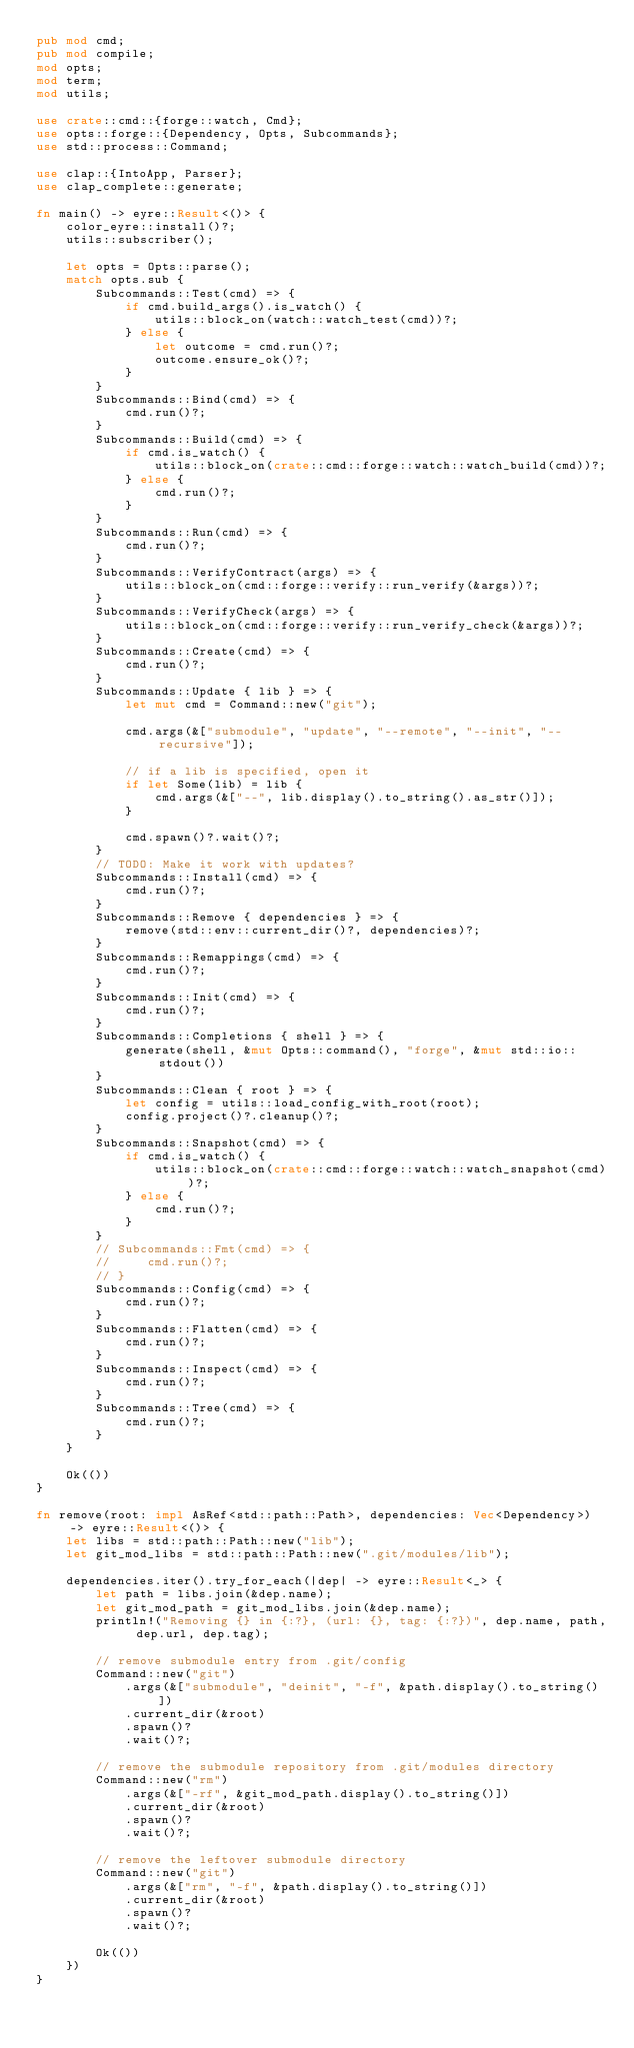Convert code to text. <code><loc_0><loc_0><loc_500><loc_500><_Rust_>pub mod cmd;
pub mod compile;
mod opts;
mod term;
mod utils;

use crate::cmd::{forge::watch, Cmd};
use opts::forge::{Dependency, Opts, Subcommands};
use std::process::Command;

use clap::{IntoApp, Parser};
use clap_complete::generate;

fn main() -> eyre::Result<()> {
    color_eyre::install()?;
    utils::subscriber();

    let opts = Opts::parse();
    match opts.sub {
        Subcommands::Test(cmd) => {
            if cmd.build_args().is_watch() {
                utils::block_on(watch::watch_test(cmd))?;
            } else {
                let outcome = cmd.run()?;
                outcome.ensure_ok()?;
            }
        }
        Subcommands::Bind(cmd) => {
            cmd.run()?;
        }
        Subcommands::Build(cmd) => {
            if cmd.is_watch() {
                utils::block_on(crate::cmd::forge::watch::watch_build(cmd))?;
            } else {
                cmd.run()?;
            }
        }
        Subcommands::Run(cmd) => {
            cmd.run()?;
        }
        Subcommands::VerifyContract(args) => {
            utils::block_on(cmd::forge::verify::run_verify(&args))?;
        }
        Subcommands::VerifyCheck(args) => {
            utils::block_on(cmd::forge::verify::run_verify_check(&args))?;
        }
        Subcommands::Create(cmd) => {
            cmd.run()?;
        }
        Subcommands::Update { lib } => {
            let mut cmd = Command::new("git");

            cmd.args(&["submodule", "update", "--remote", "--init", "--recursive"]);

            // if a lib is specified, open it
            if let Some(lib) = lib {
                cmd.args(&["--", lib.display().to_string().as_str()]);
            }

            cmd.spawn()?.wait()?;
        }
        // TODO: Make it work with updates?
        Subcommands::Install(cmd) => {
            cmd.run()?;
        }
        Subcommands::Remove { dependencies } => {
            remove(std::env::current_dir()?, dependencies)?;
        }
        Subcommands::Remappings(cmd) => {
            cmd.run()?;
        }
        Subcommands::Init(cmd) => {
            cmd.run()?;
        }
        Subcommands::Completions { shell } => {
            generate(shell, &mut Opts::command(), "forge", &mut std::io::stdout())
        }
        Subcommands::Clean { root } => {
            let config = utils::load_config_with_root(root);
            config.project()?.cleanup()?;
        }
        Subcommands::Snapshot(cmd) => {
            if cmd.is_watch() {
                utils::block_on(crate::cmd::forge::watch::watch_snapshot(cmd))?;
            } else {
                cmd.run()?;
            }
        }
        // Subcommands::Fmt(cmd) => {
        //     cmd.run()?;
        // }
        Subcommands::Config(cmd) => {
            cmd.run()?;
        }
        Subcommands::Flatten(cmd) => {
            cmd.run()?;
        }
        Subcommands::Inspect(cmd) => {
            cmd.run()?;
        }
        Subcommands::Tree(cmd) => {
            cmd.run()?;
        }
    }

    Ok(())
}

fn remove(root: impl AsRef<std::path::Path>, dependencies: Vec<Dependency>) -> eyre::Result<()> {
    let libs = std::path::Path::new("lib");
    let git_mod_libs = std::path::Path::new(".git/modules/lib");

    dependencies.iter().try_for_each(|dep| -> eyre::Result<_> {
        let path = libs.join(&dep.name);
        let git_mod_path = git_mod_libs.join(&dep.name);
        println!("Removing {} in {:?}, (url: {}, tag: {:?})", dep.name, path, dep.url, dep.tag);

        // remove submodule entry from .git/config
        Command::new("git")
            .args(&["submodule", "deinit", "-f", &path.display().to_string()])
            .current_dir(&root)
            .spawn()?
            .wait()?;

        // remove the submodule repository from .git/modules directory
        Command::new("rm")
            .args(&["-rf", &git_mod_path.display().to_string()])
            .current_dir(&root)
            .spawn()?
            .wait()?;

        // remove the leftover submodule directory
        Command::new("git")
            .args(&["rm", "-f", &path.display().to_string()])
            .current_dir(&root)
            .spawn()?
            .wait()?;

        Ok(())
    })
}
</code> 